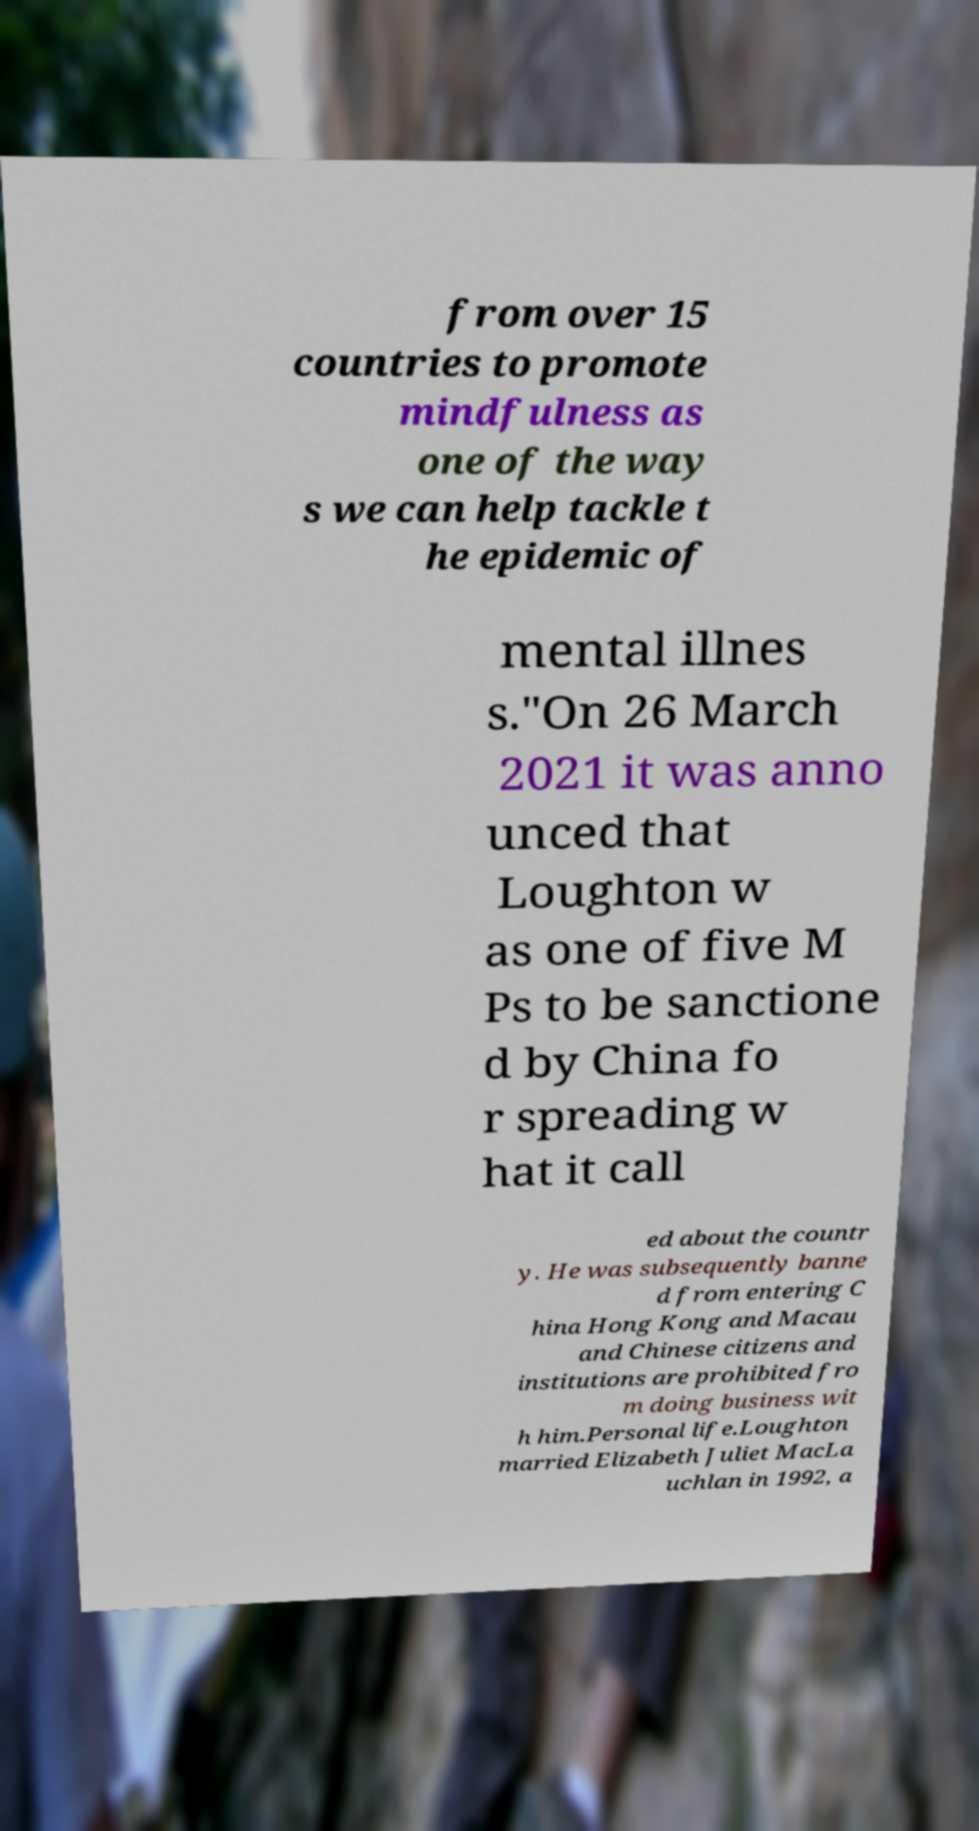Can you read and provide the text displayed in the image?This photo seems to have some interesting text. Can you extract and type it out for me? from over 15 countries to promote mindfulness as one of the way s we can help tackle t he epidemic of mental illnes s."On 26 March 2021 it was anno unced that Loughton w as one of five M Ps to be sanctione d by China fo r spreading w hat it call ed about the countr y. He was subsequently banne d from entering C hina Hong Kong and Macau and Chinese citizens and institutions are prohibited fro m doing business wit h him.Personal life.Loughton married Elizabeth Juliet MacLa uchlan in 1992, a 